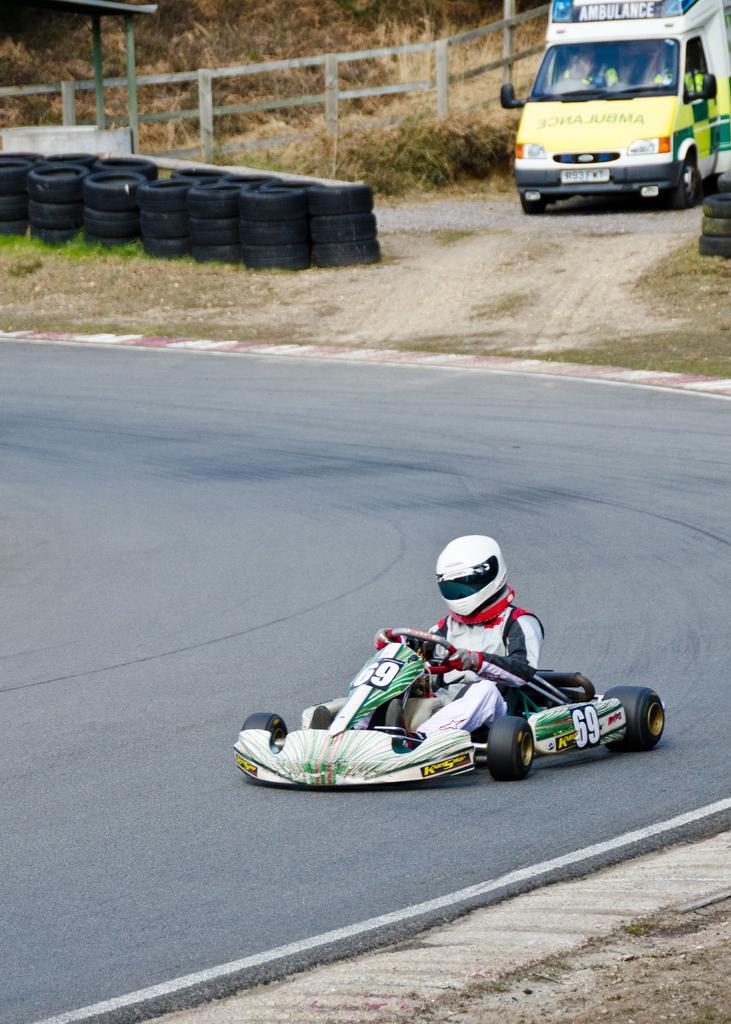How would you summarize this image in a sentence or two? In this image I can see the road and a person wearing white colored helmet and white colored dress is riding a vehicle which is white and black in color on the road. In the background I can see some grass on the ground, few black colored tires, a vehicle which is yellow and white in color, the railing and few plants. 